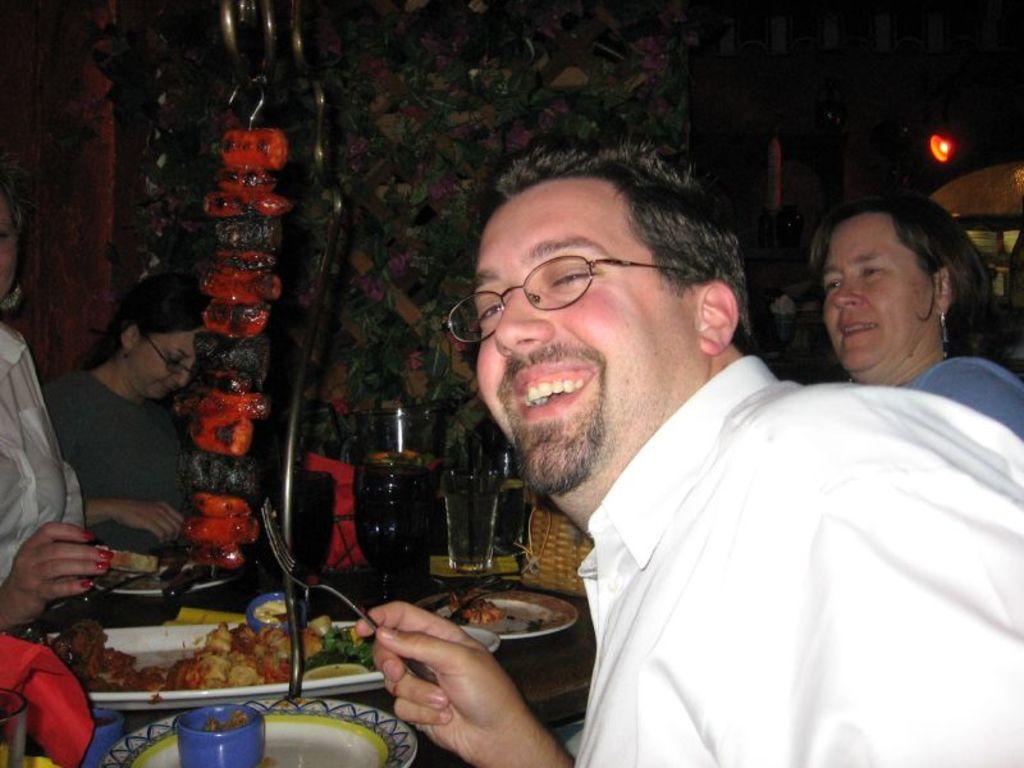Describe this image in one or two sentences. There are people, we can see plates, tray, glasses, food, basket and objects on the table. We can see, meat hanging on handle. In the background we can see leaves, flowers and light and it is dark. 